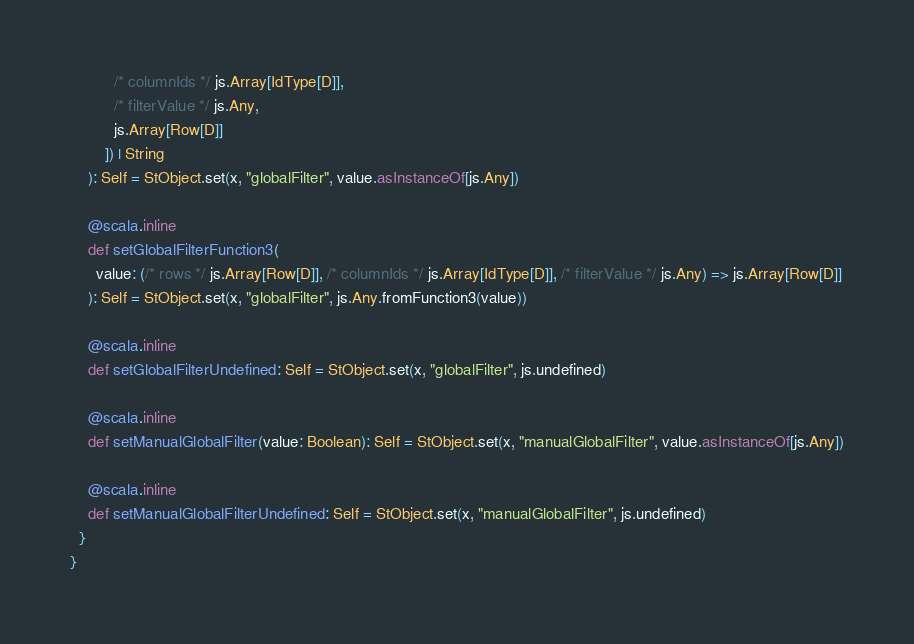Convert code to text. <code><loc_0><loc_0><loc_500><loc_500><_Scala_>          /* columnIds */ js.Array[IdType[D]], 
          /* filterValue */ js.Any, 
          js.Array[Row[D]]
        ]) | String
    ): Self = StObject.set(x, "globalFilter", value.asInstanceOf[js.Any])
    
    @scala.inline
    def setGlobalFilterFunction3(
      value: (/* rows */ js.Array[Row[D]], /* columnIds */ js.Array[IdType[D]], /* filterValue */ js.Any) => js.Array[Row[D]]
    ): Self = StObject.set(x, "globalFilter", js.Any.fromFunction3(value))
    
    @scala.inline
    def setGlobalFilterUndefined: Self = StObject.set(x, "globalFilter", js.undefined)
    
    @scala.inline
    def setManualGlobalFilter(value: Boolean): Self = StObject.set(x, "manualGlobalFilter", value.asInstanceOf[js.Any])
    
    @scala.inline
    def setManualGlobalFilterUndefined: Self = StObject.set(x, "manualGlobalFilter", js.undefined)
  }
}
</code> 